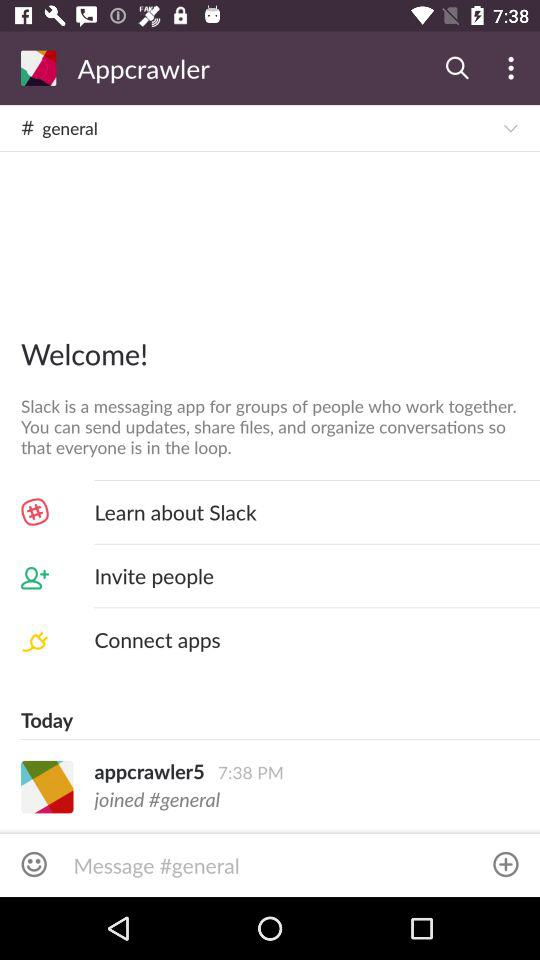What is the time shown on the screen? The time shown on the screen is 7:38 PM. 